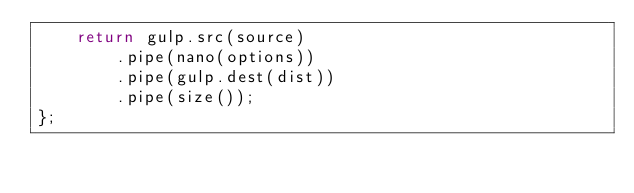<code> <loc_0><loc_0><loc_500><loc_500><_JavaScript_>    return gulp.src(source)
        .pipe(nano(options))
        .pipe(gulp.dest(dist))
        .pipe(size());
};
</code> 